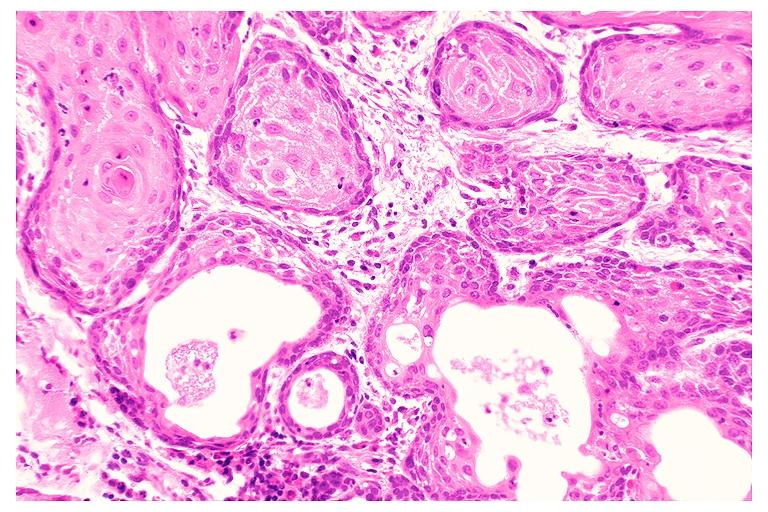s oral present?
Answer the question using a single word or phrase. Yes 